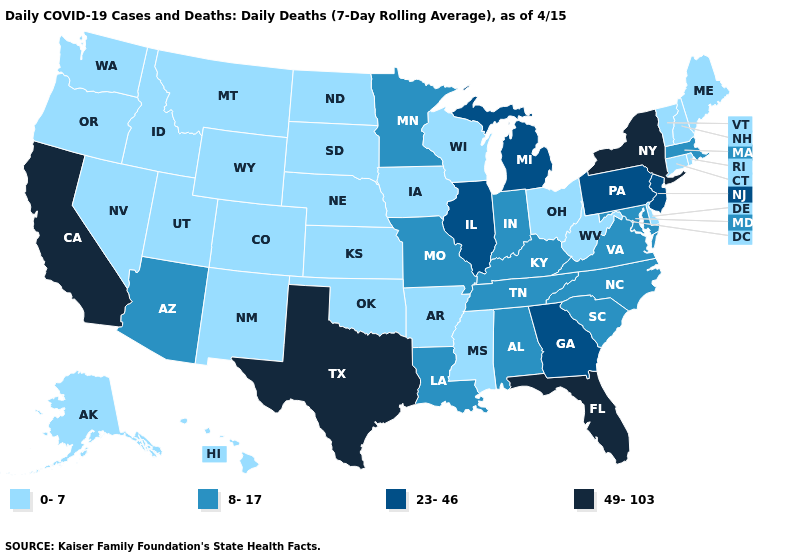Which states have the lowest value in the Northeast?
Be succinct. Connecticut, Maine, New Hampshire, Rhode Island, Vermont. Which states have the lowest value in the USA?
Keep it brief. Alaska, Arkansas, Colorado, Connecticut, Delaware, Hawaii, Idaho, Iowa, Kansas, Maine, Mississippi, Montana, Nebraska, Nevada, New Hampshire, New Mexico, North Dakota, Ohio, Oklahoma, Oregon, Rhode Island, South Dakota, Utah, Vermont, Washington, West Virginia, Wisconsin, Wyoming. What is the value of Arkansas?
Answer briefly. 0-7. What is the value of Florida?
Quick response, please. 49-103. Does the map have missing data?
Quick response, please. No. What is the lowest value in the USA?
Quick response, please. 0-7. What is the highest value in the West ?
Write a very short answer. 49-103. Among the states that border Washington , which have the highest value?
Give a very brief answer. Idaho, Oregon. Among the states that border New York , which have the highest value?
Keep it brief. New Jersey, Pennsylvania. Does New York have the same value as California?
Give a very brief answer. Yes. What is the value of Ohio?
Short answer required. 0-7. What is the lowest value in the South?
Be succinct. 0-7. Which states have the lowest value in the USA?
Short answer required. Alaska, Arkansas, Colorado, Connecticut, Delaware, Hawaii, Idaho, Iowa, Kansas, Maine, Mississippi, Montana, Nebraska, Nevada, New Hampshire, New Mexico, North Dakota, Ohio, Oklahoma, Oregon, Rhode Island, South Dakota, Utah, Vermont, Washington, West Virginia, Wisconsin, Wyoming. Does Maine have a lower value than West Virginia?
Keep it brief. No. Does New Jersey have a lower value than Florida?
Quick response, please. Yes. 